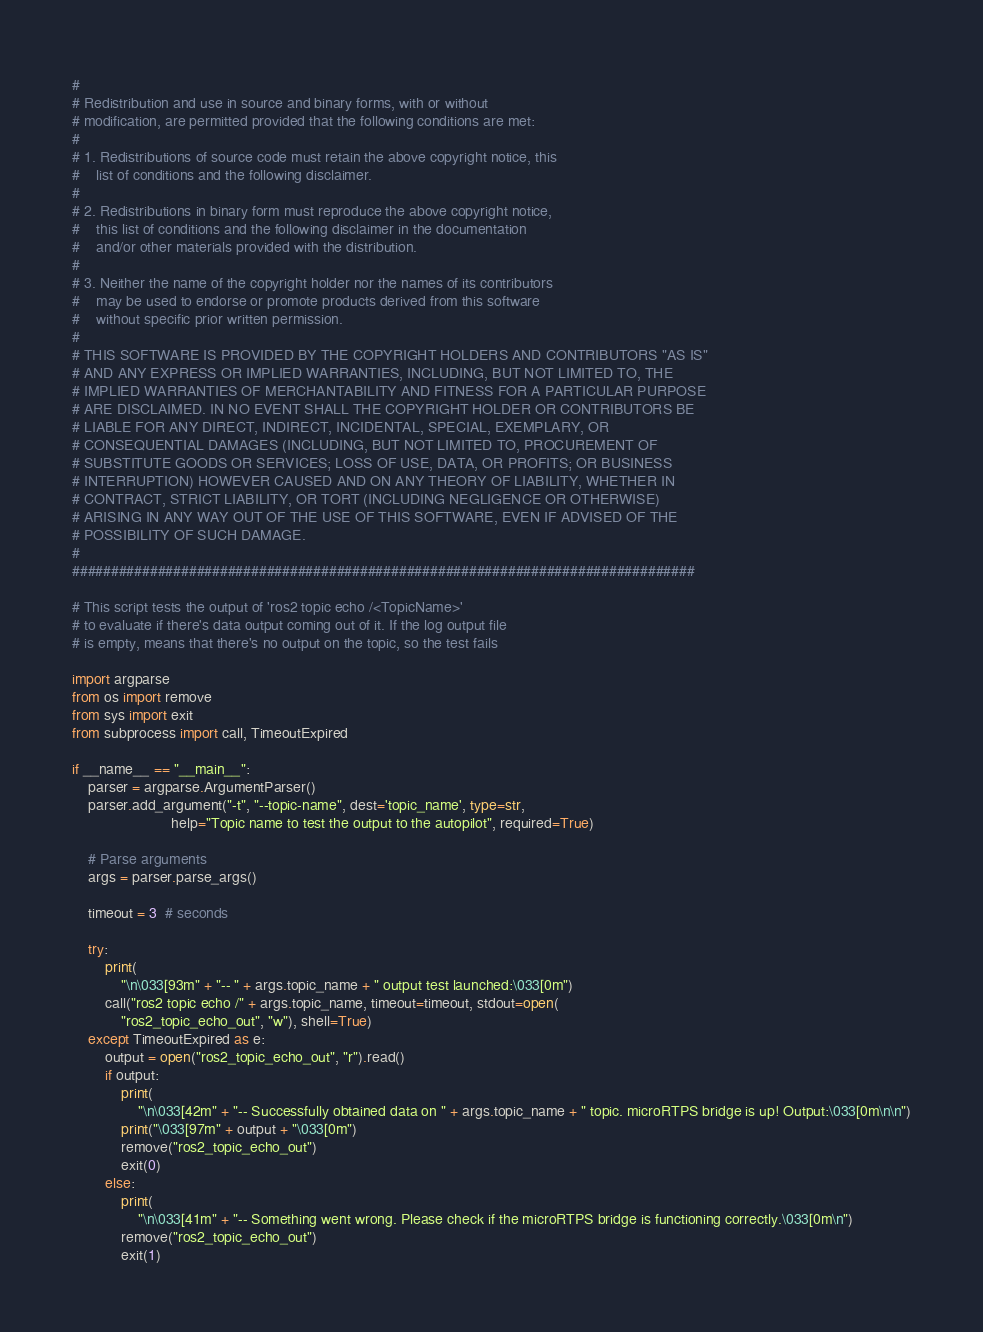<code> <loc_0><loc_0><loc_500><loc_500><_Python_>#
# Redistribution and use in source and binary forms, with or without
# modification, are permitted provided that the following conditions are met:
#
# 1. Redistributions of source code must retain the above copyright notice, this
#    list of conditions and the following disclaimer.
#
# 2. Redistributions in binary form must reproduce the above copyright notice,
#    this list of conditions and the following disclaimer in the documentation
#    and/or other materials provided with the distribution.
#
# 3. Neither the name of the copyright holder nor the names of its contributors
#    may be used to endorse or promote products derived from this software
#    without specific prior written permission.
#
# THIS SOFTWARE IS PROVIDED BY THE COPYRIGHT HOLDERS AND CONTRIBUTORS "AS IS"
# AND ANY EXPRESS OR IMPLIED WARRANTIES, INCLUDING, BUT NOT LIMITED TO, THE
# IMPLIED WARRANTIES OF MERCHANTABILITY AND FITNESS FOR A PARTICULAR PURPOSE
# ARE DISCLAIMED. IN NO EVENT SHALL THE COPYRIGHT HOLDER OR CONTRIBUTORS BE
# LIABLE FOR ANY DIRECT, INDIRECT, INCIDENTAL, SPECIAL, EXEMPLARY, OR
# CONSEQUENTIAL DAMAGES (INCLUDING, BUT NOT LIMITED TO, PROCUREMENT OF
# SUBSTITUTE GOODS OR SERVICES; LOSS OF USE, DATA, OR PROFITS; OR BUSINESS
# INTERRUPTION) HOWEVER CAUSED AND ON ANY THEORY OF LIABILITY, WHETHER IN
# CONTRACT, STRICT LIABILITY, OR TORT (INCLUDING NEGLIGENCE OR OTHERWISE)
# ARISING IN ANY WAY OUT OF THE USE OF THIS SOFTWARE, EVEN IF ADVISED OF THE
# POSSIBILITY OF SUCH DAMAGE.
#
################################################################################

# This script tests the output of 'ros2 topic echo /<TopicName>'
# to evaluate if there's data output coming out of it. If the log output file
# is empty, means that there's no output on the topic, so the test fails

import argparse
from os import remove
from sys import exit
from subprocess import call, TimeoutExpired

if __name__ == "__main__":
    parser = argparse.ArgumentParser()
    parser.add_argument("-t", "--topic-name", dest='topic_name', type=str,
                        help="Topic name to test the output to the autopilot", required=True)

    # Parse arguments
    args = parser.parse_args()

    timeout = 3  # seconds

    try:
        print(
            "\n\033[93m" + "-- " + args.topic_name + " output test launched:\033[0m")
        call("ros2 topic echo /" + args.topic_name, timeout=timeout, stdout=open(
            "ros2_topic_echo_out", "w"), shell=True)
    except TimeoutExpired as e:
        output = open("ros2_topic_echo_out", "r").read()
        if output:
            print(
                "\n\033[42m" + "-- Successfully obtained data on " + args.topic_name + " topic. microRTPS bridge is up! Output:\033[0m\n\n")
            print("\033[97m" + output + "\033[0m")
            remove("ros2_topic_echo_out")
            exit(0)
        else:
            print(
                "\n\033[41m" + "-- Something went wrong. Please check if the microRTPS bridge is functioning correctly.\033[0m\n")
            remove("ros2_topic_echo_out")
            exit(1)
</code> 